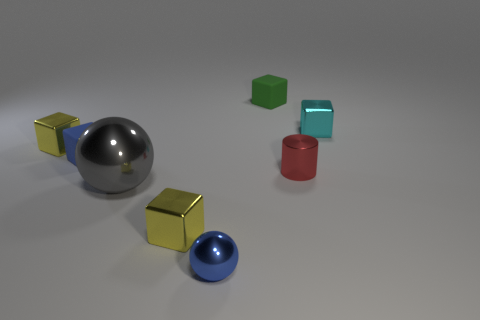Subtract all cyan cylinders. How many yellow blocks are left? 2 Add 1 yellow metal things. How many objects exist? 9 Subtract all green blocks. How many blocks are left? 4 Subtract all tiny cyan metallic cubes. How many cubes are left? 4 Subtract all cylinders. How many objects are left? 7 Subtract all gray blocks. Subtract all gray balls. How many blocks are left? 5 Subtract all blue metal cubes. Subtract all big shiny balls. How many objects are left? 7 Add 2 tiny red cylinders. How many tiny red cylinders are left? 3 Add 2 big shiny spheres. How many big shiny spheres exist? 3 Subtract 2 yellow cubes. How many objects are left? 6 